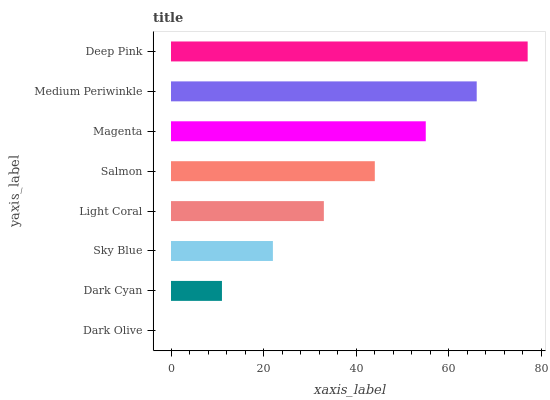Is Dark Olive the minimum?
Answer yes or no. Yes. Is Deep Pink the maximum?
Answer yes or no. Yes. Is Dark Cyan the minimum?
Answer yes or no. No. Is Dark Cyan the maximum?
Answer yes or no. No. Is Dark Cyan greater than Dark Olive?
Answer yes or no. Yes. Is Dark Olive less than Dark Cyan?
Answer yes or no. Yes. Is Dark Olive greater than Dark Cyan?
Answer yes or no. No. Is Dark Cyan less than Dark Olive?
Answer yes or no. No. Is Salmon the high median?
Answer yes or no. Yes. Is Light Coral the low median?
Answer yes or no. Yes. Is Deep Pink the high median?
Answer yes or no. No. Is Salmon the low median?
Answer yes or no. No. 